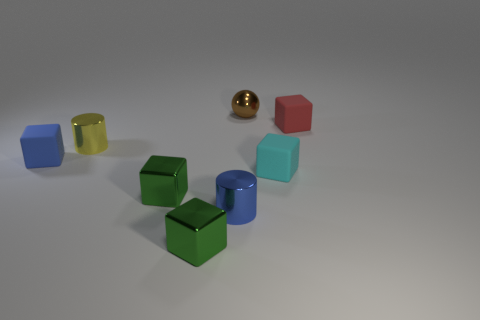Subtract all red cubes. How many cubes are left? 4 Subtract all blue cubes. How many cubes are left? 4 Subtract all purple blocks. Subtract all brown spheres. How many blocks are left? 5 Add 2 small red blocks. How many objects exist? 10 Subtract all blocks. How many objects are left? 3 Add 6 tiny brown objects. How many tiny brown objects exist? 7 Subtract 1 cyan blocks. How many objects are left? 7 Subtract all small metallic cylinders. Subtract all tiny yellow things. How many objects are left? 5 Add 6 small yellow cylinders. How many small yellow cylinders are left? 7 